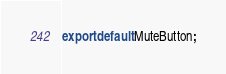Convert code to text. <code><loc_0><loc_0><loc_500><loc_500><_JavaScript_>export default MuteButton;</code> 